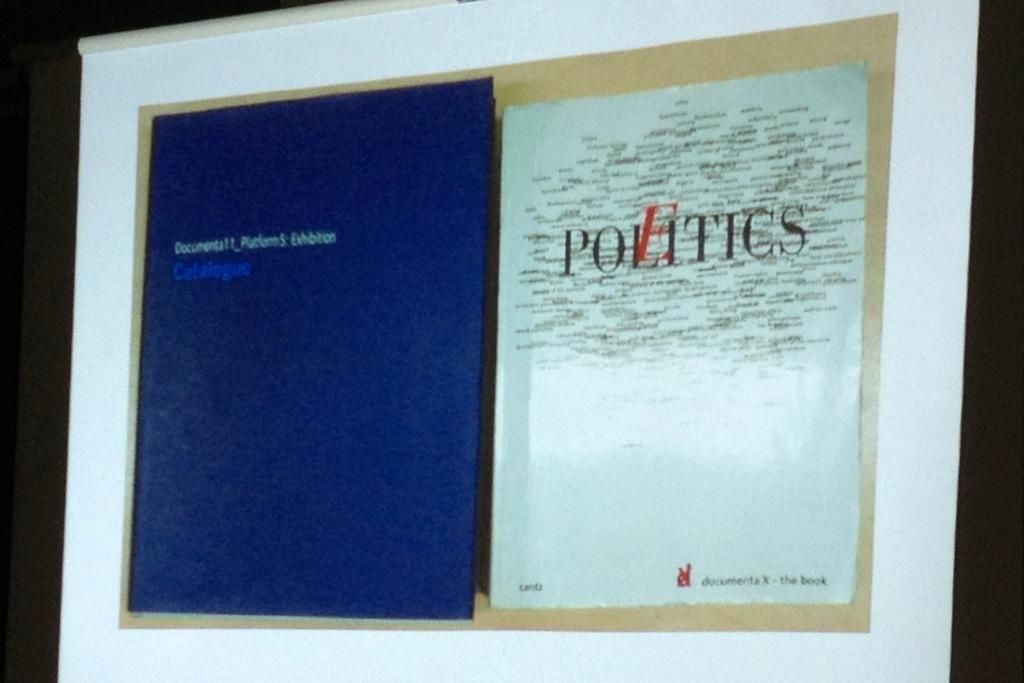<image>
Offer a succinct explanation of the picture presented. A frame which has a blue catalogue on the left and something labelled Poleitics on the right. 